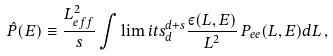Convert formula to latex. <formula><loc_0><loc_0><loc_500><loc_500>\hat { P } ( E ) \equiv \frac { L _ { e f f } ^ { 2 } } { s } \int \lim i t s _ { d } ^ { d + s } \frac { \varepsilon ( L , E ) } { L ^ { 2 } } \, P _ { e e } ( L , E ) d L \, ,</formula> 